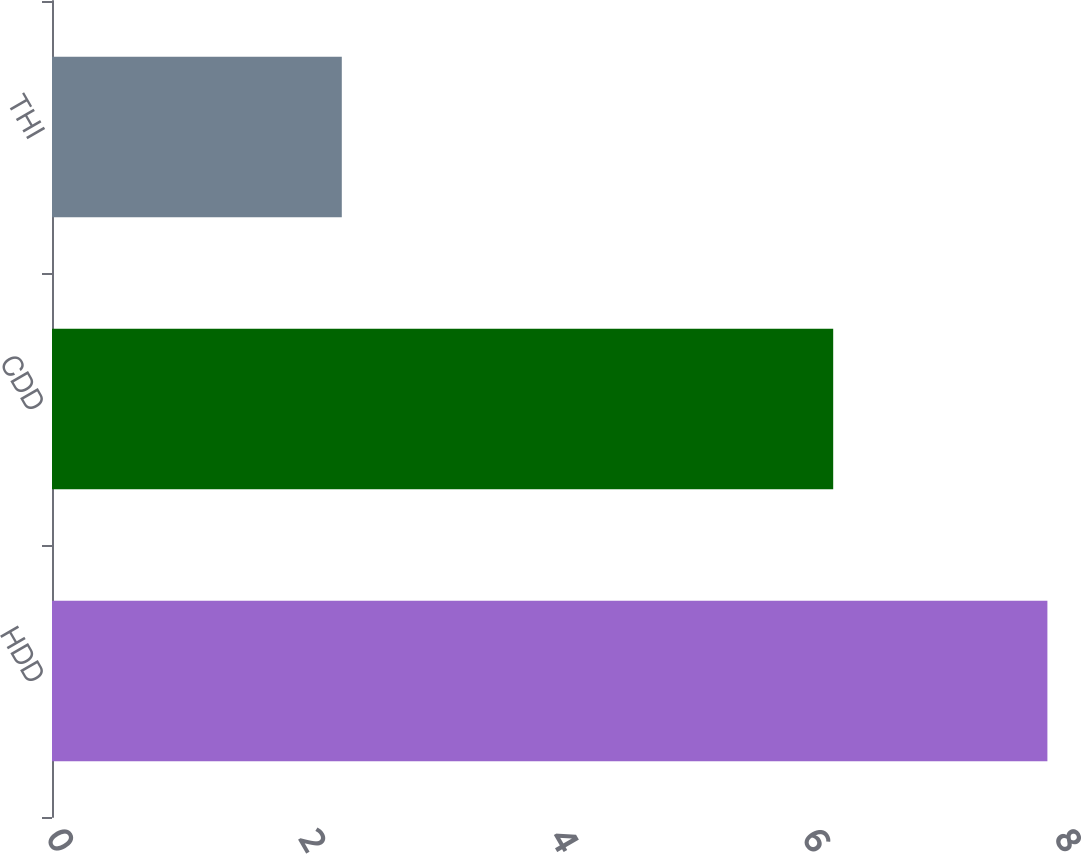Convert chart to OTSL. <chart><loc_0><loc_0><loc_500><loc_500><bar_chart><fcel>HDD<fcel>CDD<fcel>THI<nl><fcel>7.9<fcel>6.2<fcel>2.3<nl></chart> 